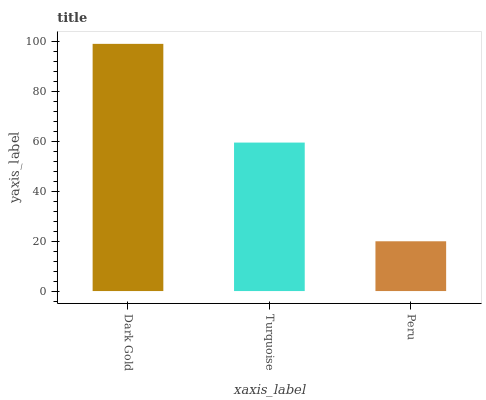Is Peru the minimum?
Answer yes or no. Yes. Is Dark Gold the maximum?
Answer yes or no. Yes. Is Turquoise the minimum?
Answer yes or no. No. Is Turquoise the maximum?
Answer yes or no. No. Is Dark Gold greater than Turquoise?
Answer yes or no. Yes. Is Turquoise less than Dark Gold?
Answer yes or no. Yes. Is Turquoise greater than Dark Gold?
Answer yes or no. No. Is Dark Gold less than Turquoise?
Answer yes or no. No. Is Turquoise the high median?
Answer yes or no. Yes. Is Turquoise the low median?
Answer yes or no. Yes. Is Peru the high median?
Answer yes or no. No. Is Dark Gold the low median?
Answer yes or no. No. 